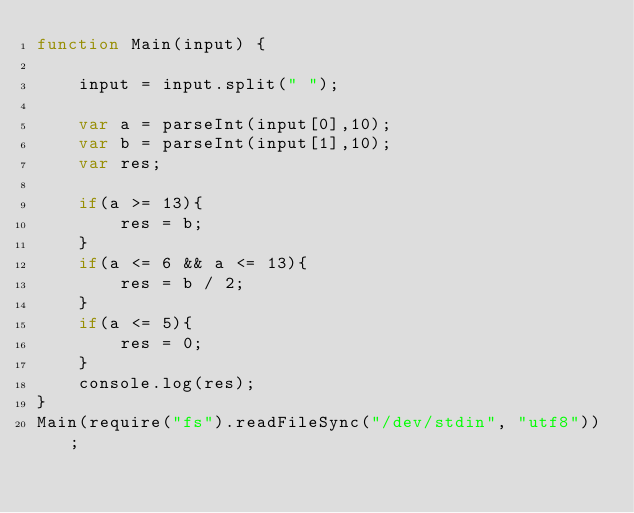Convert code to text. <code><loc_0><loc_0><loc_500><loc_500><_JavaScript_>function Main(input) {
	
    input = input.split(" ");
    
    var a = parseInt(input[0],10);
    var b = parseInt(input[1],10);
    var res;

    if(a >= 13){
        res = b;
    }
    if(a <= 6 && a <= 13){
        res = b / 2;
    }
    if(a <= 5){
        res = 0;
    }
    console.log(res);
}
Main(require("fs").readFileSync("/dev/stdin", "utf8"));</code> 